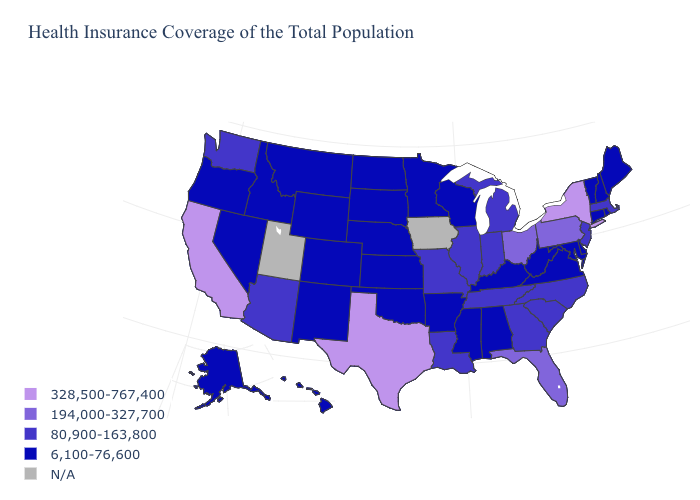Name the states that have a value in the range 6,100-76,600?
Give a very brief answer. Alabama, Alaska, Arkansas, Colorado, Connecticut, Delaware, Hawaii, Idaho, Kansas, Kentucky, Maine, Maryland, Minnesota, Mississippi, Montana, Nebraska, Nevada, New Hampshire, New Mexico, North Dakota, Oklahoma, Oregon, Rhode Island, South Dakota, Vermont, Virginia, West Virginia, Wisconsin, Wyoming. Name the states that have a value in the range 328,500-767,400?
Write a very short answer. California, New York, Texas. Name the states that have a value in the range 328,500-767,400?
Be succinct. California, New York, Texas. Is the legend a continuous bar?
Give a very brief answer. No. Name the states that have a value in the range N/A?
Concise answer only. Iowa, Utah. What is the value of Rhode Island?
Write a very short answer. 6,100-76,600. Is the legend a continuous bar?
Keep it brief. No. What is the lowest value in the USA?
Write a very short answer. 6,100-76,600. What is the highest value in the USA?
Write a very short answer. 328,500-767,400. Does the map have missing data?
Short answer required. Yes. Which states hav the highest value in the Northeast?
Be succinct. New York. Name the states that have a value in the range 194,000-327,700?
Answer briefly. Florida, Ohio, Pennsylvania. Does Ohio have the lowest value in the USA?
Answer briefly. No. Name the states that have a value in the range 6,100-76,600?
Answer briefly. Alabama, Alaska, Arkansas, Colorado, Connecticut, Delaware, Hawaii, Idaho, Kansas, Kentucky, Maine, Maryland, Minnesota, Mississippi, Montana, Nebraska, Nevada, New Hampshire, New Mexico, North Dakota, Oklahoma, Oregon, Rhode Island, South Dakota, Vermont, Virginia, West Virginia, Wisconsin, Wyoming. Name the states that have a value in the range N/A?
Answer briefly. Iowa, Utah. 